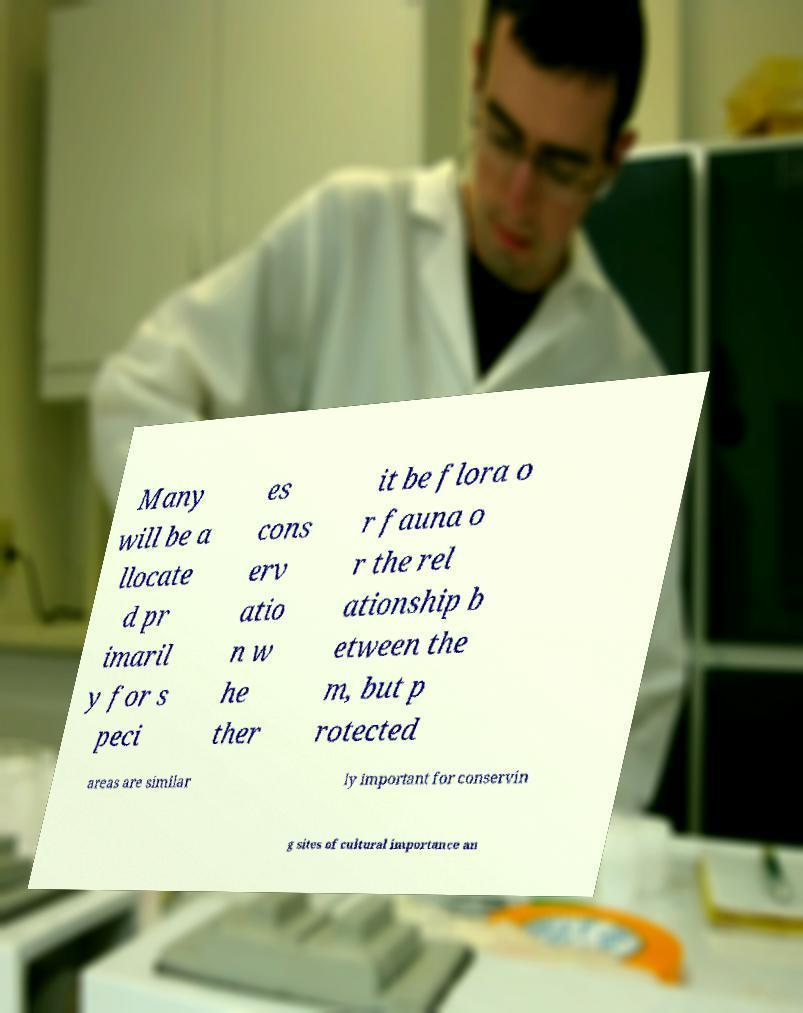What messages or text are displayed in this image? I need them in a readable, typed format. Many will be a llocate d pr imaril y for s peci es cons erv atio n w he ther it be flora o r fauna o r the rel ationship b etween the m, but p rotected areas are similar ly important for conservin g sites of cultural importance an 